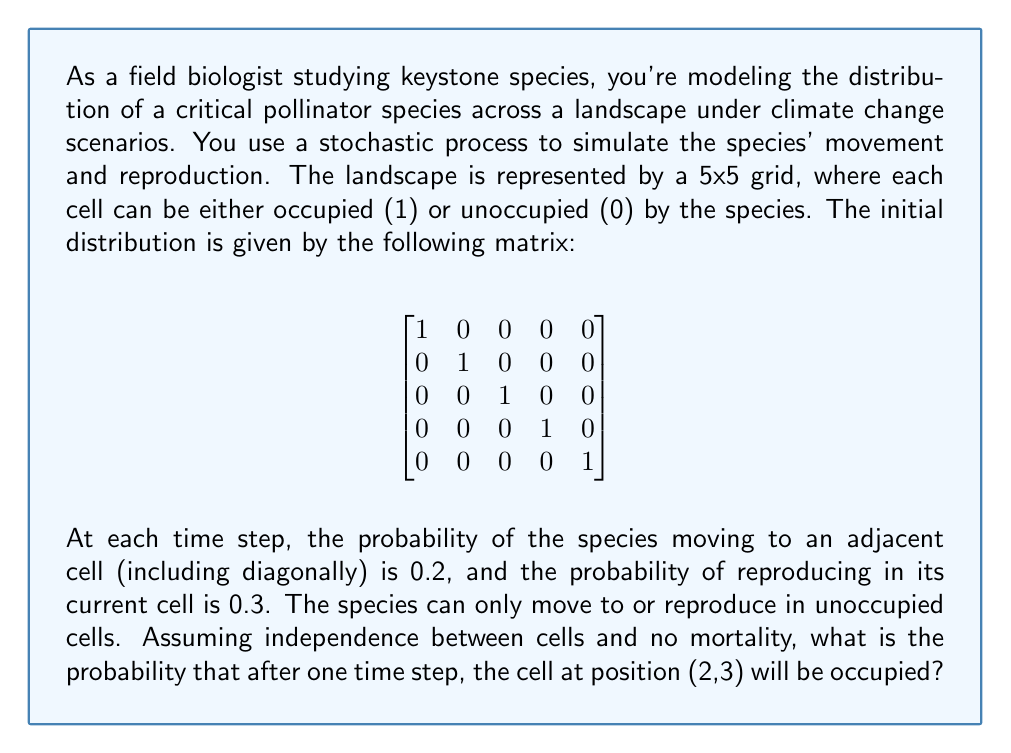Provide a solution to this math problem. Let's approach this step-by-step:

1) First, we need to identify the cells that could contribute to occupying cell (2,3). These are:
   - (1,2), (1,3), (1,4)
   - (2,2), (2,4)
   - (3,2), (3,3), (3,4)

2) From the initial distribution, we see that only cell (2,2) is occupied among these.

3) The species in cell (2,2) can either move to (2,3) or reproduce to fill (2,3).

4) Probability of moving to (2,3):
   - There are 8 adjacent cells to (2,2), and the probability of moving to any of them is 0.2.
   - So, the probability of moving specifically to (2,3) is $\frac{0.2}{8} = 0.025$

5) Probability of reproducing in (2,3):
   - The probability of reproducing is 0.3, and there are 8 adjacent cells.
   - So, the probability of reproducing specifically in (2,3) is $\frac{0.3}{8} = 0.0375$

6) The probability of cell (2,3) being occupied is the probability of either event occurring:
   $P(\text{occupied}) = P(\text{move}) + P(\text{reproduce}) - P(\text{move and reproduce})$

7) Since the events are mutually exclusive (the species can't both move to and reproduce in the same cell in one time step), the last term is zero.

8) Therefore, $P(\text{occupied}) = 0.025 + 0.0375 = 0.0625$
Answer: 0.0625 